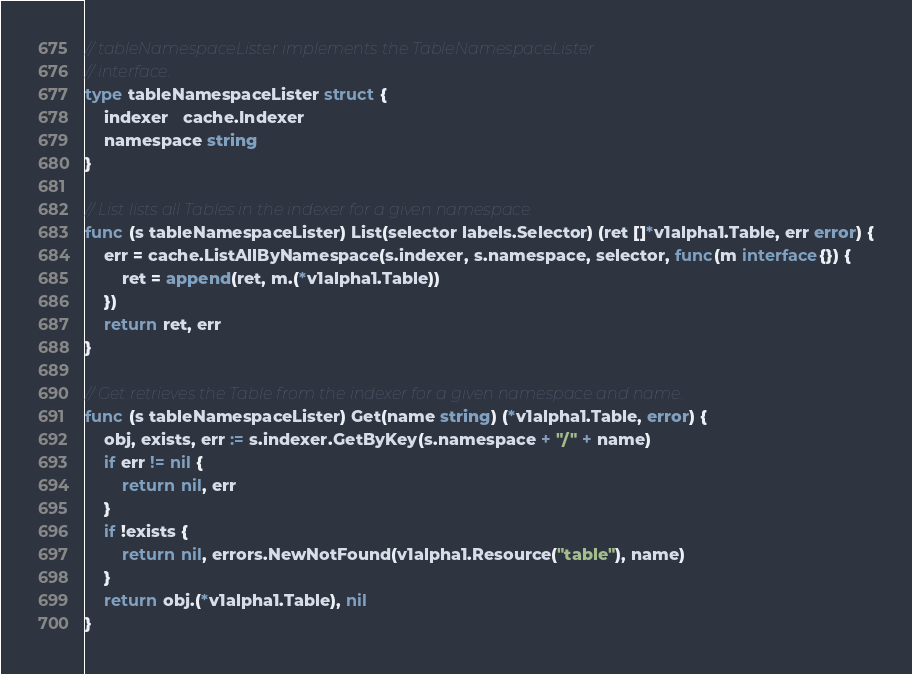<code> <loc_0><loc_0><loc_500><loc_500><_Go_>
// tableNamespaceLister implements the TableNamespaceLister
// interface.
type tableNamespaceLister struct {
	indexer   cache.Indexer
	namespace string
}

// List lists all Tables in the indexer for a given namespace.
func (s tableNamespaceLister) List(selector labels.Selector) (ret []*v1alpha1.Table, err error) {
	err = cache.ListAllByNamespace(s.indexer, s.namespace, selector, func(m interface{}) {
		ret = append(ret, m.(*v1alpha1.Table))
	})
	return ret, err
}

// Get retrieves the Table from the indexer for a given namespace and name.
func (s tableNamespaceLister) Get(name string) (*v1alpha1.Table, error) {
	obj, exists, err := s.indexer.GetByKey(s.namespace + "/" + name)
	if err != nil {
		return nil, err
	}
	if !exists {
		return nil, errors.NewNotFound(v1alpha1.Resource("table"), name)
	}
	return obj.(*v1alpha1.Table), nil
}
</code> 